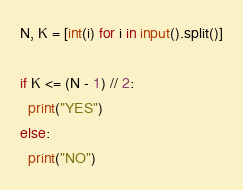<code> <loc_0><loc_0><loc_500><loc_500><_Python_>N, K = [int(i) for i in input().split()]
 
if K <= (N - 1) // 2:
  print("YES")
else:
  print("NO")</code> 